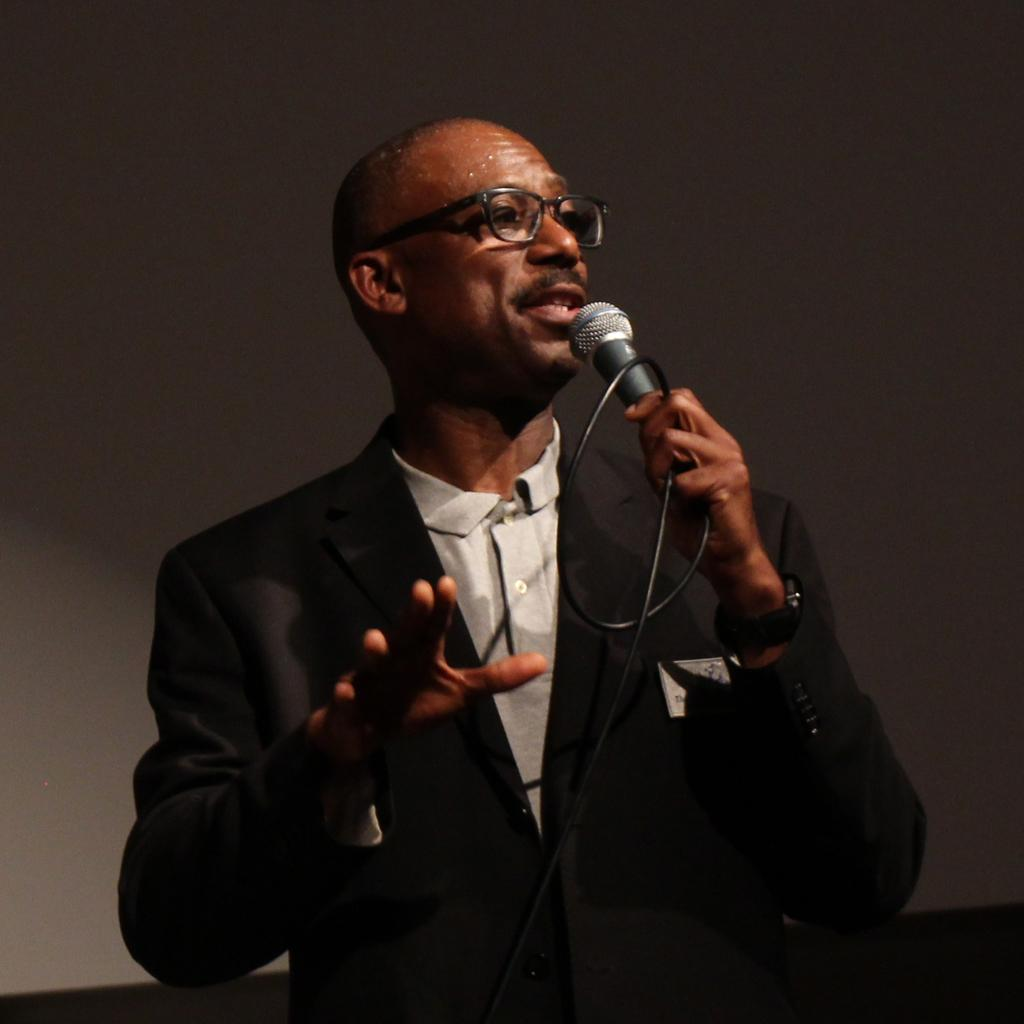What is the man in the image doing? The man is standing in the image and talking. What is the man holding in his hand? The man is holding a microphone in his hand. What can be seen in the background of the image? There is a wall in the background of the image. What type of hammer can be seen in the man's hand in the image? There is no hammer present in the image; the man is holding a microphone. What is the man laughing about in the image? The man is not laughing in the image; he is talking. 